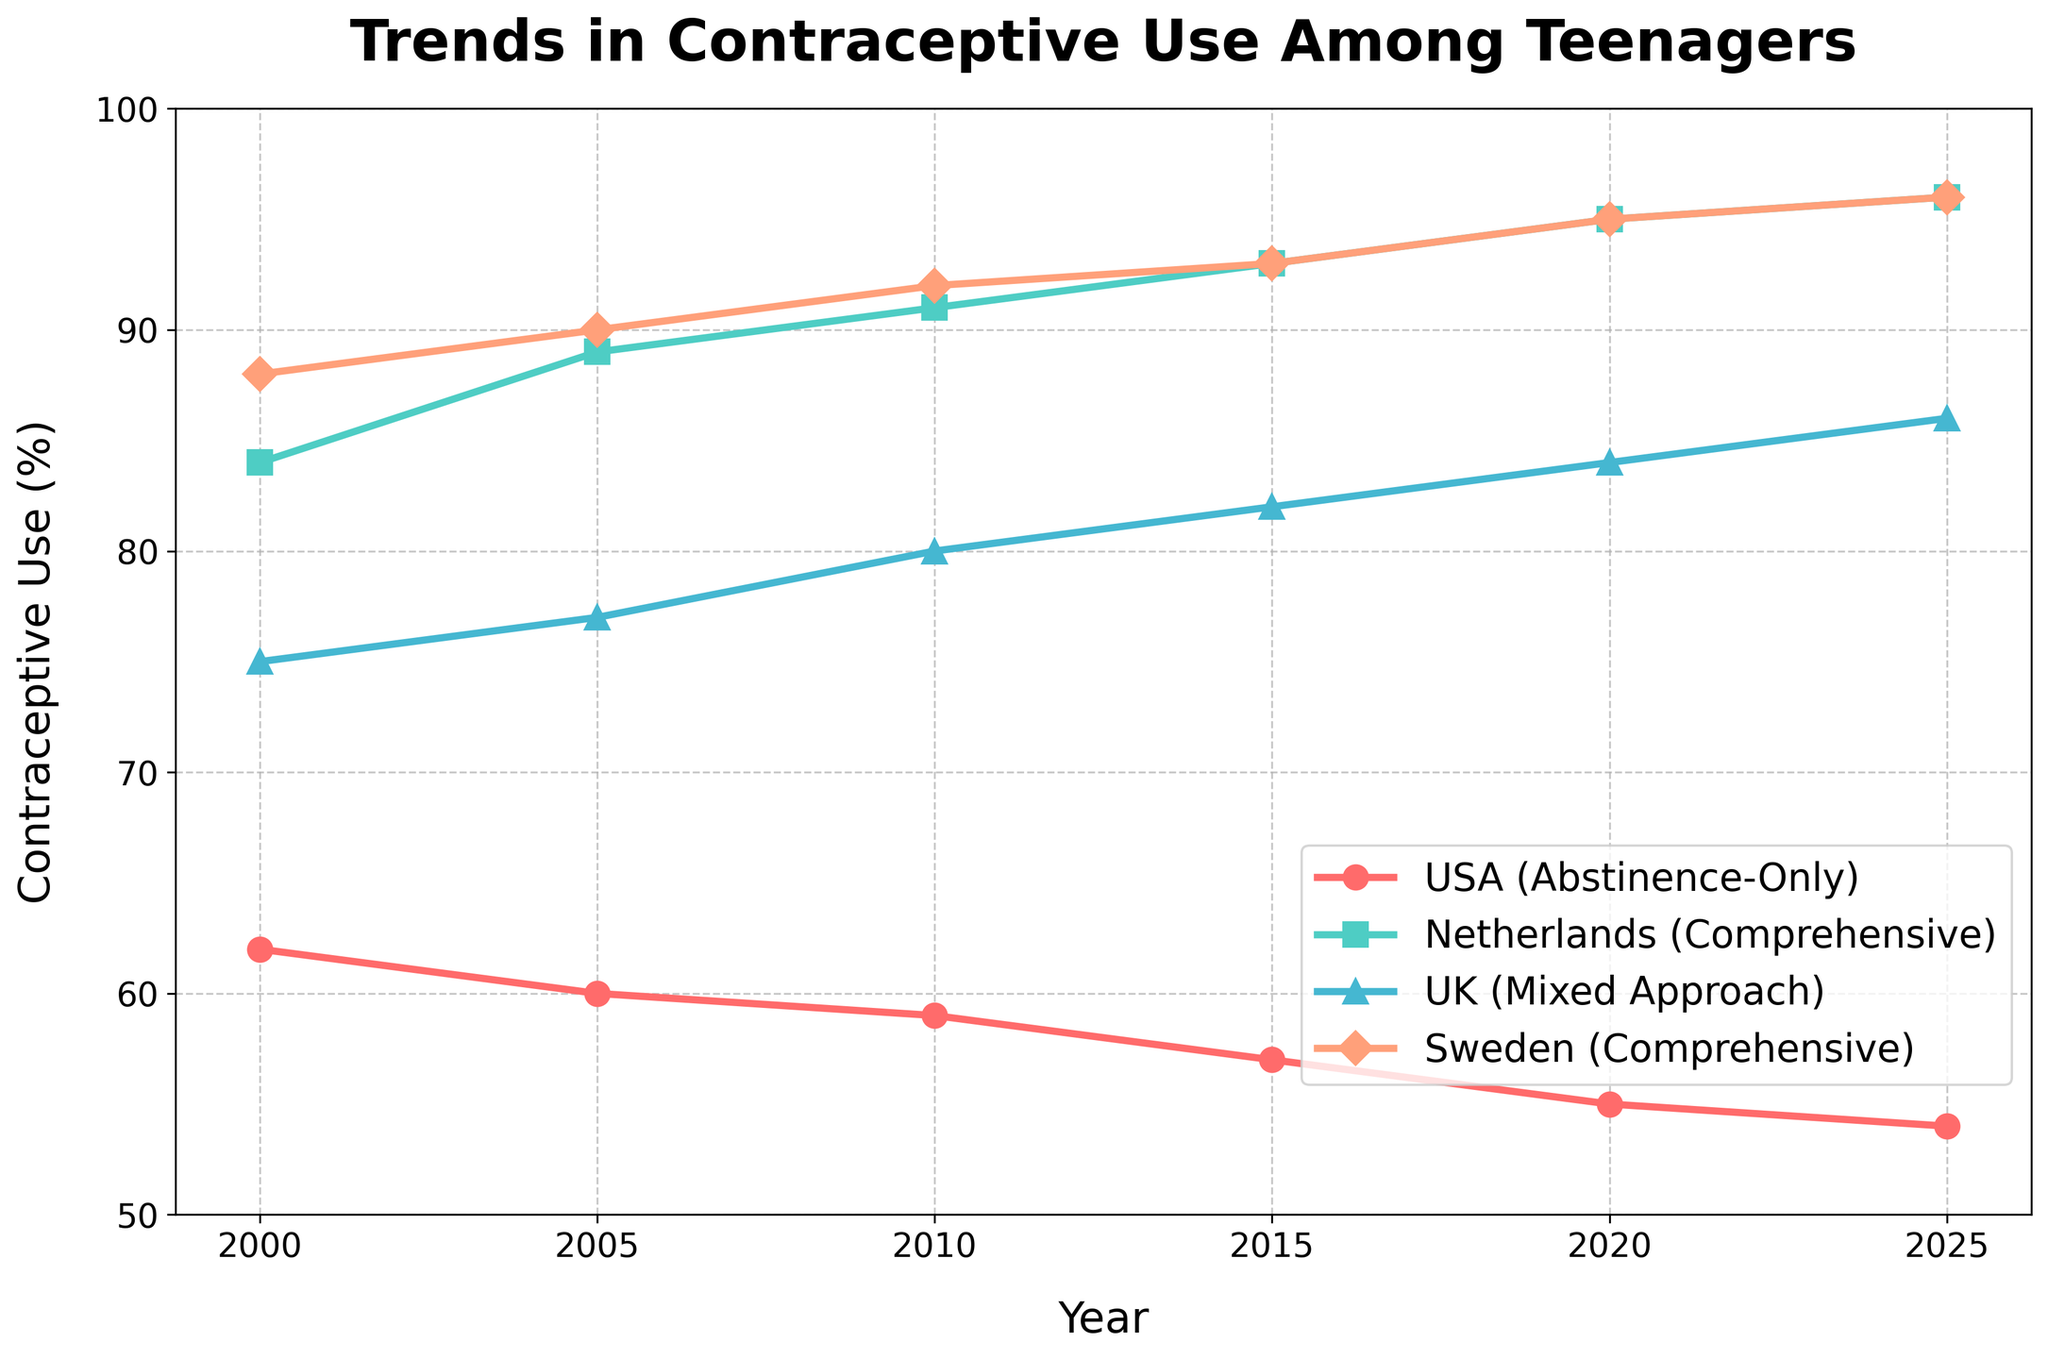which country has the lowest percentage of contraceptive use among teenagers in 2020? In 2020, the USA has the lowest percentage of contraceptive use among teenagers compared to the Netherlands, UK, and Sweden. This can be seen from the bottom line corresponding to the USA's data point in 2020.
Answer: USA Between 2000 and 2020, which country's contraceptive use among teenagers increased the most? The Netherlands saw the contraceptive use increase from 84% in 2000 to 95% in 2020. The increase is 95 - 84 = 11 percentage points, which is higher than the increase in other countries.
Answer: Netherlands Which year shows the biggest difference in percentage of contraceptive use between the USA and Sweden? In 2020, the difference between the USA (55%) and Sweden (95%) is the largest. The difference is 95 - 55 = 40 percentage points, which is the highest compared to other years.
Answer: 2020 On average, how much did contraceptive use by teenagers in the UK increase every five years between 2000 and 2025? To find the average increase, calculate the total increase from 2000 (75%) to 2025 (86%) which is 86 - 75 = 11. There are 5 intervals of 5 years within this period, so the average increase per interval is 11 / 5 = 2.2 percentage points.
Answer: 2.2 By how much did contraceptive use among teenagers in the Netherlands increase from 2005 to 2015? In 2005, the contraceptive use in the Netherlands was 89%. By 2015 it increased to 93%. The difference is 93 - 89 = 4 percentage points.
Answer: 4 In what year did the UK first surpass the 80% mark in contraceptive use among teenagers? The UK surpassed the 80% mark in 2010 with a value of 80%.
Answer: 2010 How does the trend in contraceptive use among teenagers in the USA compare to that in Sweden over the years? The USA shows a decreasing trend from 62% in 2000 to 54% in 2025, while Sweden shows an increasing trend from 88% in 2000 to 96% in 2025.
Answer: The USA decreases, Sweden increases What is the average contraceptive use in Sweden from 2000 to 2025? To find the average, sum the values for Sweden from 2000 to 2025 and divide by the number of data points: (88 + 90 + 92 + 93 + 95 + 96) / 6 = 554 / 6 = 92.3%.
Answer: 92.3 In which year is the contraceptive use in all countries closest in value? In 2000, the contraceptive use rates are closest with values: USA (62), Netherlands (84), UK (75), Sweden (88). The spread between the highest and lowest values is relatively smaller in this year compared to others.
Answer: 2000 